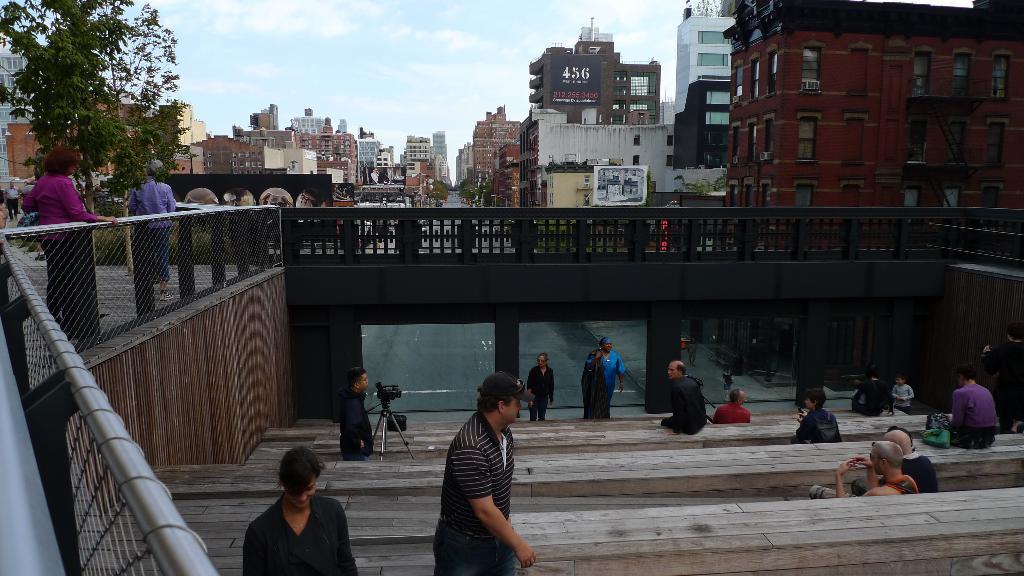In one or two sentences, can you explain what this image depicts? In this image I can see number of people were few of them sitting and standing. I can see a man standing with his camera. In the background I can see a tree and number of buildings. I can also see few more trees over there. I can see sky. 